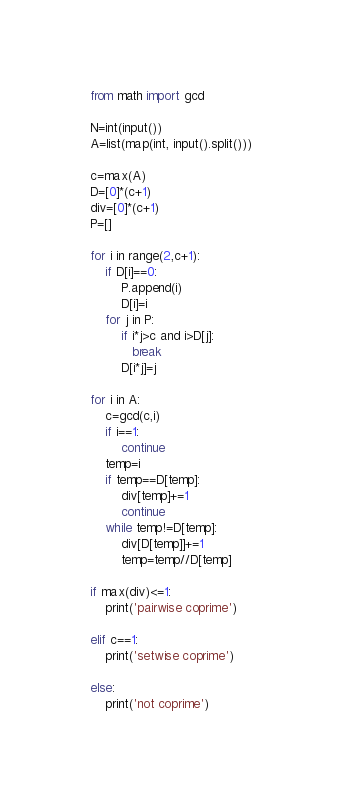<code> <loc_0><loc_0><loc_500><loc_500><_Python_>from math import gcd

N=int(input())
A=list(map(int, input().split()))

c=max(A)
D=[0]*(c+1)
div=[0]*(c+1)
P=[]

for i in range(2,c+1):
    if D[i]==0:
        P.append(i)
        D[i]=i
    for j in P:
        if i*j>c and i>D[j]:
           break
        D[i*j]=j

for i in A:
    c=gcd(c,i)
    if i==1:
        continue
    temp=i
    if temp==D[temp]:
        div[temp]+=1
        continue
    while temp!=D[temp]:
        div[D[temp]]+=1
        temp=temp//D[temp]

if max(div)<=1:
    print('pairwise coprime')

elif c==1:
    print('setwise coprime')

else:
    print('not coprime')</code> 